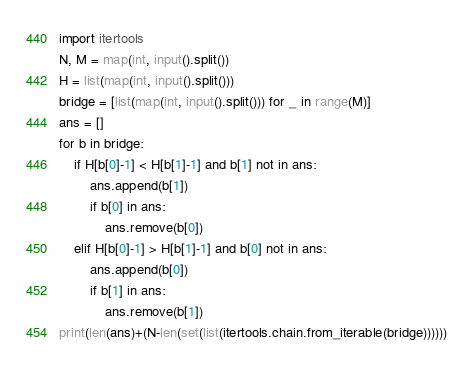Convert code to text. <code><loc_0><loc_0><loc_500><loc_500><_Python_>import itertools
N, M = map(int, input().split())
H = list(map(int, input().split()))
bridge = [list(map(int, input().split())) for _ in range(M)]
ans = []
for b in bridge:
    if H[b[0]-1] < H[b[1]-1] and b[1] not in ans:
        ans.append(b[1])
        if b[0] in ans:
            ans.remove(b[0])
    elif H[b[0]-1] > H[b[1]-1] and b[0] not in ans:
        ans.append(b[0])
        if b[1] in ans:
            ans.remove(b[1])
print(len(ans)+(N-len(set(list(itertools.chain.from_iterable(bridge))))))</code> 